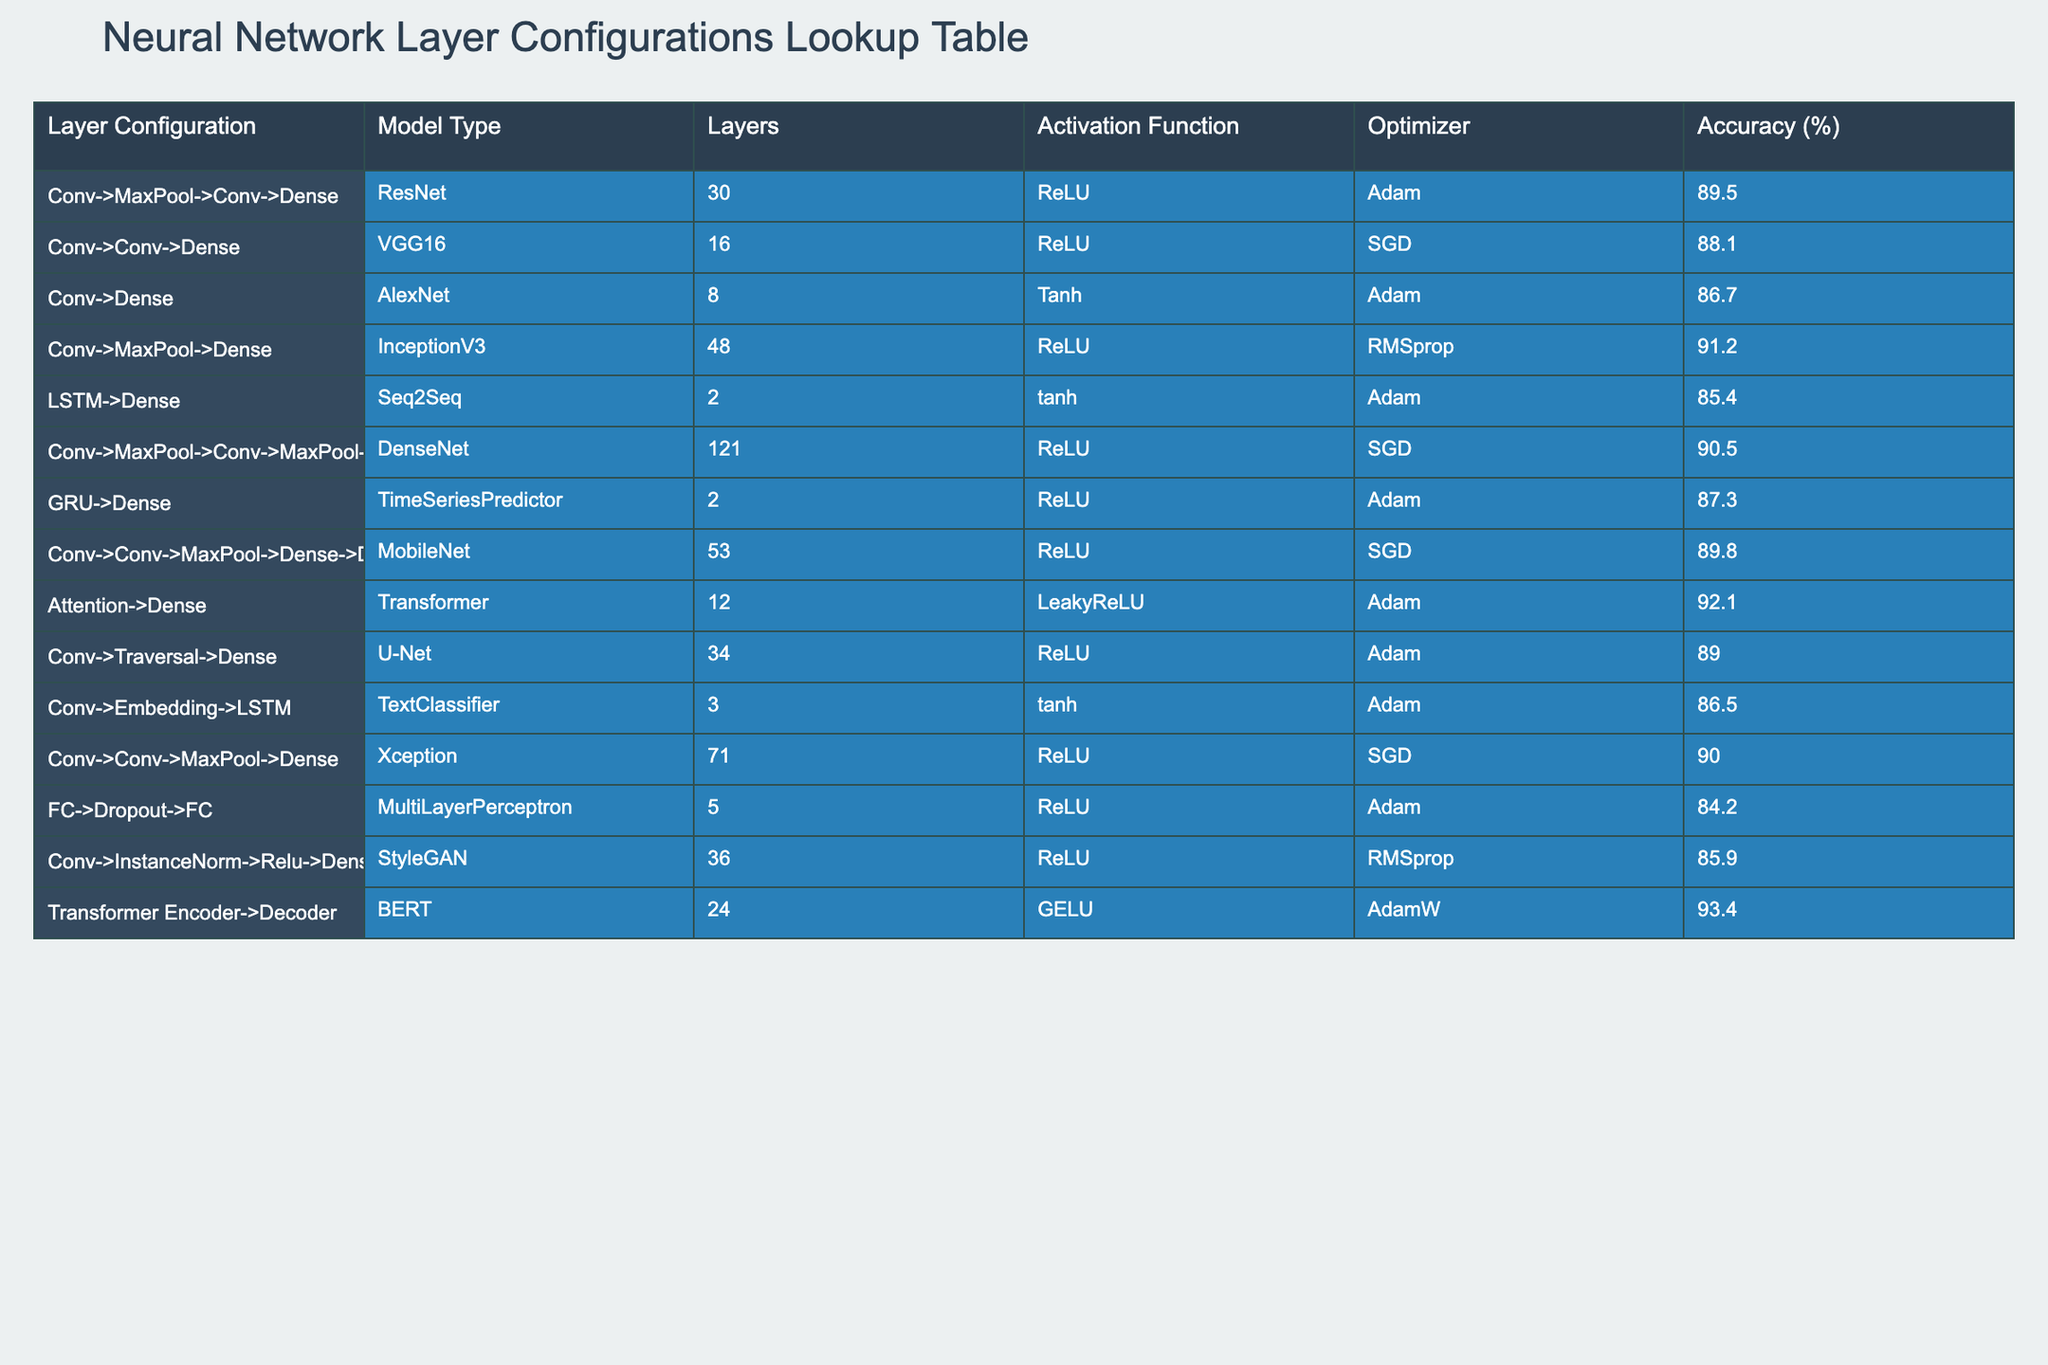What is the accuracy of the InceptionV3 model using the Conv->MaxPool->Dense configuration? The InceptionV3 model is listed as having an accuracy of 91.2% for the configuration that includes Conv->MaxPool->Dense. This can be found directly in the table under the corresponding row.
Answer: 91.2% Which model configuration has the highest accuracy? Looking through the accuracies listed, the model with the highest accuracy is the Transformer with an accuracy of 93.4%. This was determined by comparing all the accuracy percentages provided in the table.
Answer: 93.4% Is the average accuracy of models using the ReLU activation function higher than those using the Tanh activation function? The accuracies of the models using ReLU are 89.5, 91.2, 90.5, 89.8, 90.0, and 92.1, which sum up to 523. The average is 523/6 = 87.17. The models using Tanh have accuracies of 86.7, 85.4, and 86.5, which sum up to 258. The average is 258/3 = 86.0. Since 87.17 > 86.0, the average for ReLU is indeed higher.
Answer: Yes How many layers does the DenseNet model have? The DenseNet model is configured with a total of 121 layers, as indicated directly in the table in the corresponding row.
Answer: 121 Is there any configuration that combines both Convolutional layers and LSTMs? Upon reviewing the provided table, the configurations listed do not include any combination of Conv layers and LSTMs. Therefore, the answer must be that there isn’t such a configuration.
Answer: No What is the difference in accuracy between the VGG16 and the DenseNet model? The accuracy of VGG16 is 88.1% while that of DenseNet is 90.5%. To find the difference, we subtract the VGG16 accuracy from that of DenseNet: 90.5 - 88.1 = 2.4.
Answer: 2.4 Which optimizer is used by the BERT model? The table specifies that the BERT model configuration utilizes the AdamW optimizer. This information can be found directly in the table under the corresponding row for BERT.
Answer: AdamW What is the median accuracy of all the listed models? To find the median, we first need to list the accuracies in ascending order: 84.2, 85.4, 85.9, 86.5, 86.7, 88.1, 89.0, 89.5, 89.8, 90.0, 90.5, 91.2, 92.1, 93.4. With 14 values, the median is the average of the 7th and 8th values: (89.0 + 89.5) / 2 = 89.25.
Answer: 89.25 Is the StyleGAN model's accuracy above 86%? By checking the StyleGAN row in the table, we see that its accuracy is 85.9%, which is below 86%. Therefore, the answer is based on this direct check in the table.
Answer: No 